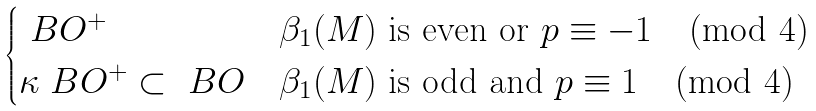Convert formula to latex. <formula><loc_0><loc_0><loc_500><loc_500>\begin{cases} \ B O ^ { + } & \text {$\beta_{1}(M)$ is even or $p\equiv -1 \pmod{4}$} \\ \kappa \ B O ^ { + } \subset \ B O & \text {$\beta_{1}(M)$ is odd and $p\equiv 1 \pmod{4}$} \end{cases}</formula> 